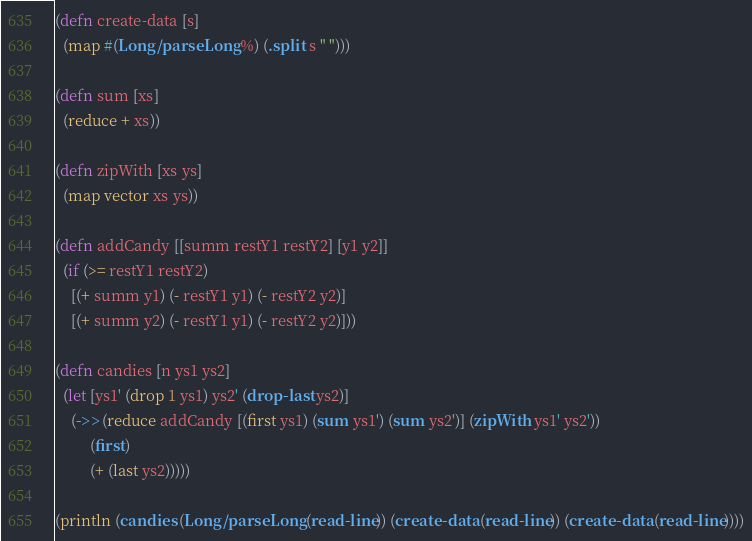Convert code to text. <code><loc_0><loc_0><loc_500><loc_500><_Clojure_>(defn create-data [s]
  (map #(Long/parseLong %) (.split s " ")))

(defn sum [xs]
  (reduce + xs))

(defn zipWith [xs ys]
  (map vector xs ys))

(defn addCandy [[summ restY1 restY2] [y1 y2]]
  (if (>= restY1 restY2) 
    [(+ summ y1) (- restY1 y1) (- restY2 y2)]
    [(+ summ y2) (- restY1 y1) (- restY2 y2)]))
  
(defn candies [n ys1 ys2]
  (let [ys1' (drop 1 ys1) ys2' (drop-last ys2)]
    (->> (reduce addCandy [(first ys1) (sum ys1') (sum ys2')] (zipWith ys1' ys2'))
         (first)
         (+ (last ys2)))))

(println (candies (Long/parseLong (read-line)) (create-data (read-line)) (create-data (read-line))))</code> 